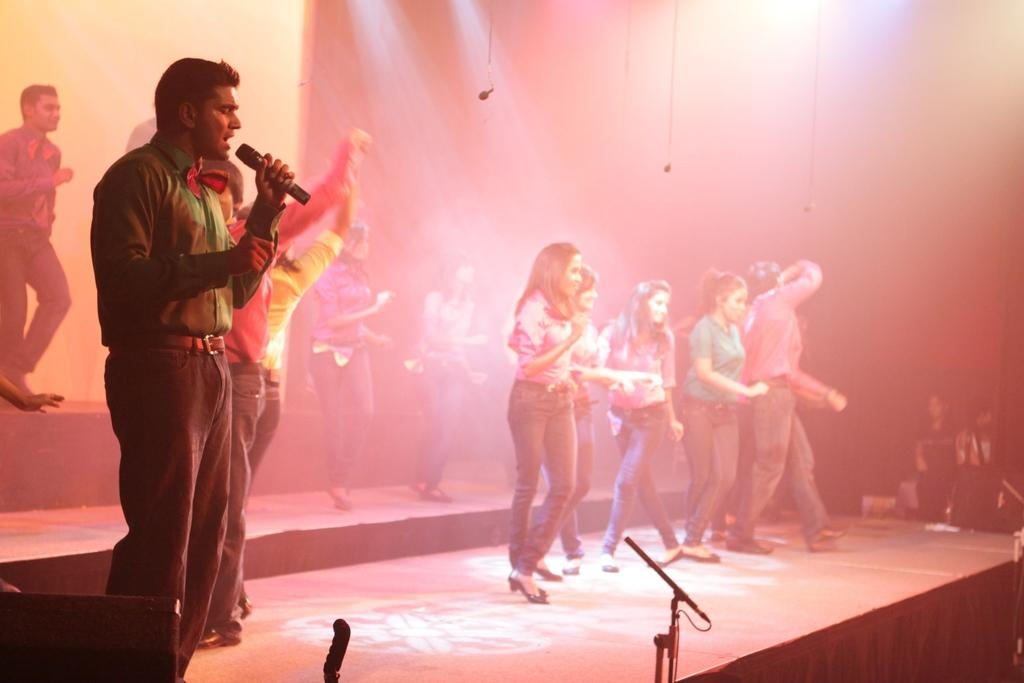What is happening in the image? There is a group of people in the image, and they are standing on a stage. Can you describe any specific details about the people on the stage? One man is wearing a green shirt, and he is holding a microphone in his hand. What type of rod is the beggar using to collect coins in the image? There is no beggar or rod present in the image. How does the man's voice sound when he speaks into the microphone? The image does not provide information about the man's voice or how it sounds when he speaks into the microphone. 